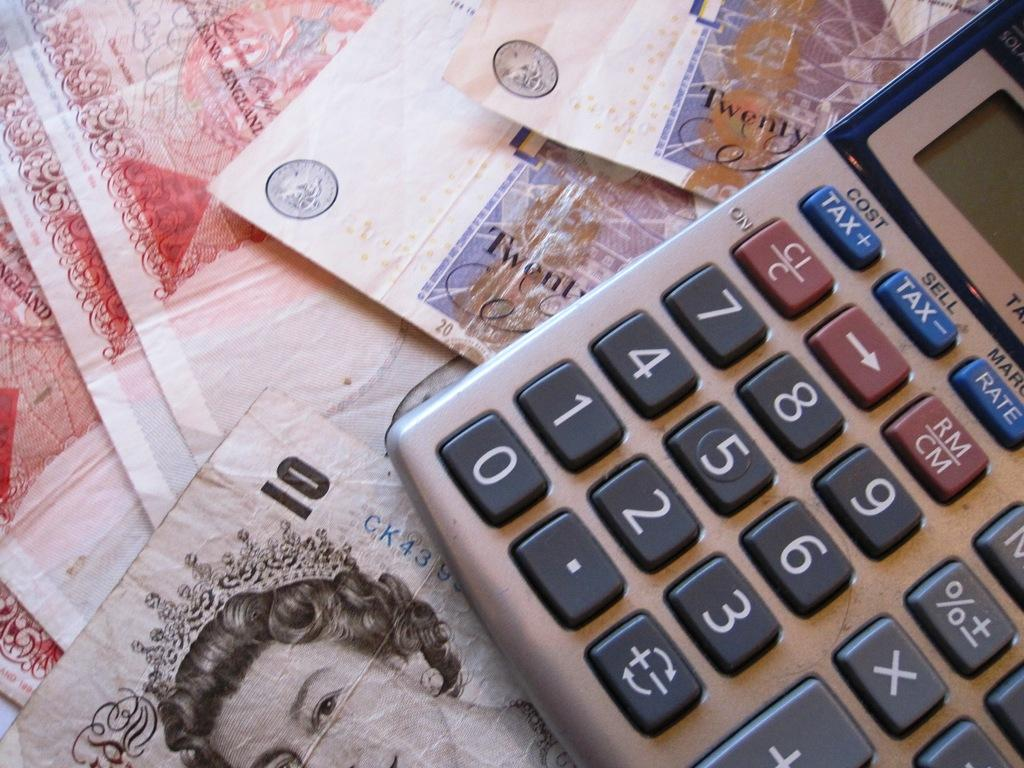<image>
Share a concise interpretation of the image provided. A calculator sitting on top of several twenty and ten pound notes 